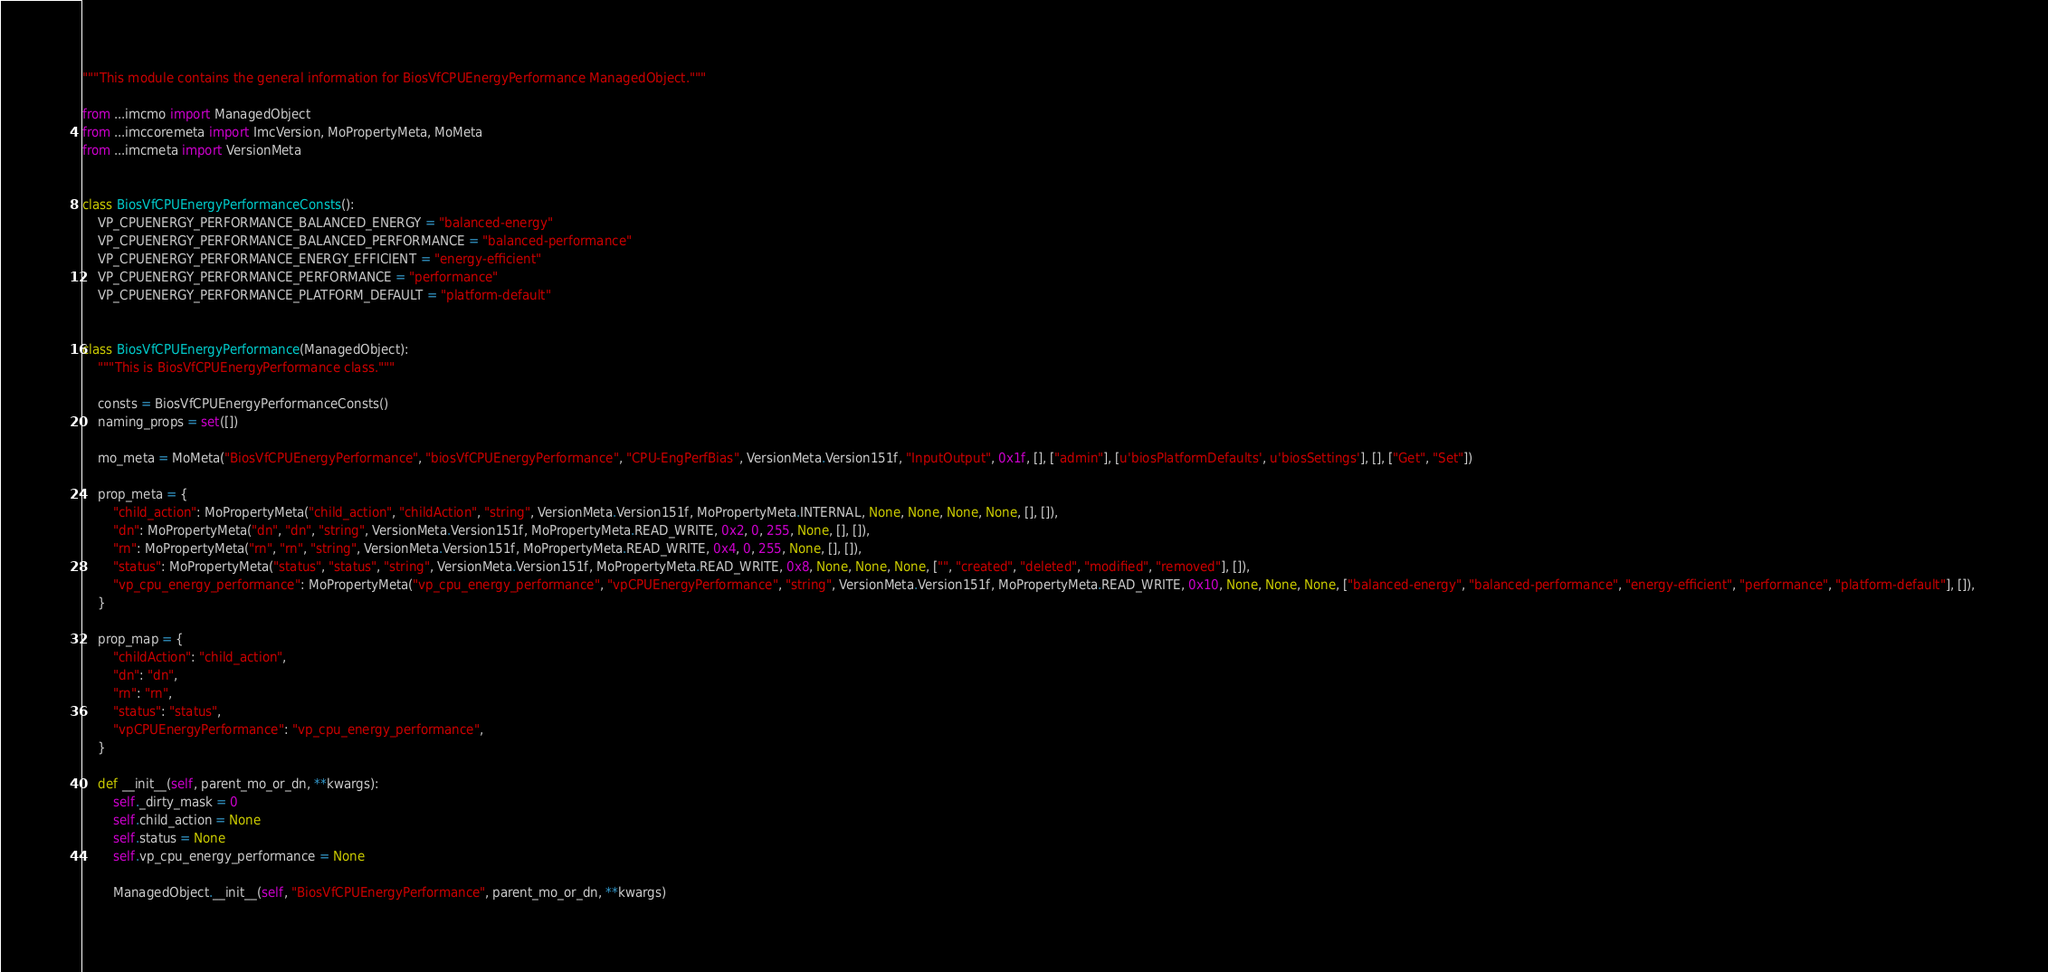Convert code to text. <code><loc_0><loc_0><loc_500><loc_500><_Python_>"""This module contains the general information for BiosVfCPUEnergyPerformance ManagedObject."""

from ...imcmo import ManagedObject
from ...imccoremeta import ImcVersion, MoPropertyMeta, MoMeta
from ...imcmeta import VersionMeta


class BiosVfCPUEnergyPerformanceConsts():
    VP_CPUENERGY_PERFORMANCE_BALANCED_ENERGY = "balanced-energy"
    VP_CPUENERGY_PERFORMANCE_BALANCED_PERFORMANCE = "balanced-performance"
    VP_CPUENERGY_PERFORMANCE_ENERGY_EFFICIENT = "energy-efficient"
    VP_CPUENERGY_PERFORMANCE_PERFORMANCE = "performance"
    VP_CPUENERGY_PERFORMANCE_PLATFORM_DEFAULT = "platform-default"


class BiosVfCPUEnergyPerformance(ManagedObject):
    """This is BiosVfCPUEnergyPerformance class."""

    consts = BiosVfCPUEnergyPerformanceConsts()
    naming_props = set([])

    mo_meta = MoMeta("BiosVfCPUEnergyPerformance", "biosVfCPUEnergyPerformance", "CPU-EngPerfBias", VersionMeta.Version151f, "InputOutput", 0x1f, [], ["admin"], [u'biosPlatformDefaults', u'biosSettings'], [], ["Get", "Set"])

    prop_meta = {
        "child_action": MoPropertyMeta("child_action", "childAction", "string", VersionMeta.Version151f, MoPropertyMeta.INTERNAL, None, None, None, None, [], []), 
        "dn": MoPropertyMeta("dn", "dn", "string", VersionMeta.Version151f, MoPropertyMeta.READ_WRITE, 0x2, 0, 255, None, [], []), 
        "rn": MoPropertyMeta("rn", "rn", "string", VersionMeta.Version151f, MoPropertyMeta.READ_WRITE, 0x4, 0, 255, None, [], []), 
        "status": MoPropertyMeta("status", "status", "string", VersionMeta.Version151f, MoPropertyMeta.READ_WRITE, 0x8, None, None, None, ["", "created", "deleted", "modified", "removed"], []), 
        "vp_cpu_energy_performance": MoPropertyMeta("vp_cpu_energy_performance", "vpCPUEnergyPerformance", "string", VersionMeta.Version151f, MoPropertyMeta.READ_WRITE, 0x10, None, None, None, ["balanced-energy", "balanced-performance", "energy-efficient", "performance", "platform-default"], []), 
    }

    prop_map = {
        "childAction": "child_action", 
        "dn": "dn", 
        "rn": "rn", 
        "status": "status", 
        "vpCPUEnergyPerformance": "vp_cpu_energy_performance", 
    }

    def __init__(self, parent_mo_or_dn, **kwargs):
        self._dirty_mask = 0
        self.child_action = None
        self.status = None
        self.vp_cpu_energy_performance = None

        ManagedObject.__init__(self, "BiosVfCPUEnergyPerformance", parent_mo_or_dn, **kwargs)

</code> 